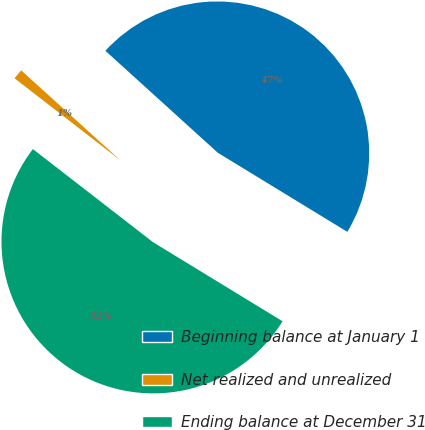Convert chart. <chart><loc_0><loc_0><loc_500><loc_500><pie_chart><fcel>Beginning balance at January 1<fcel>Net realized and unrealized<fcel>Ending balance at December 31<nl><fcel>47.0%<fcel>1.23%<fcel>51.77%<nl></chart> 